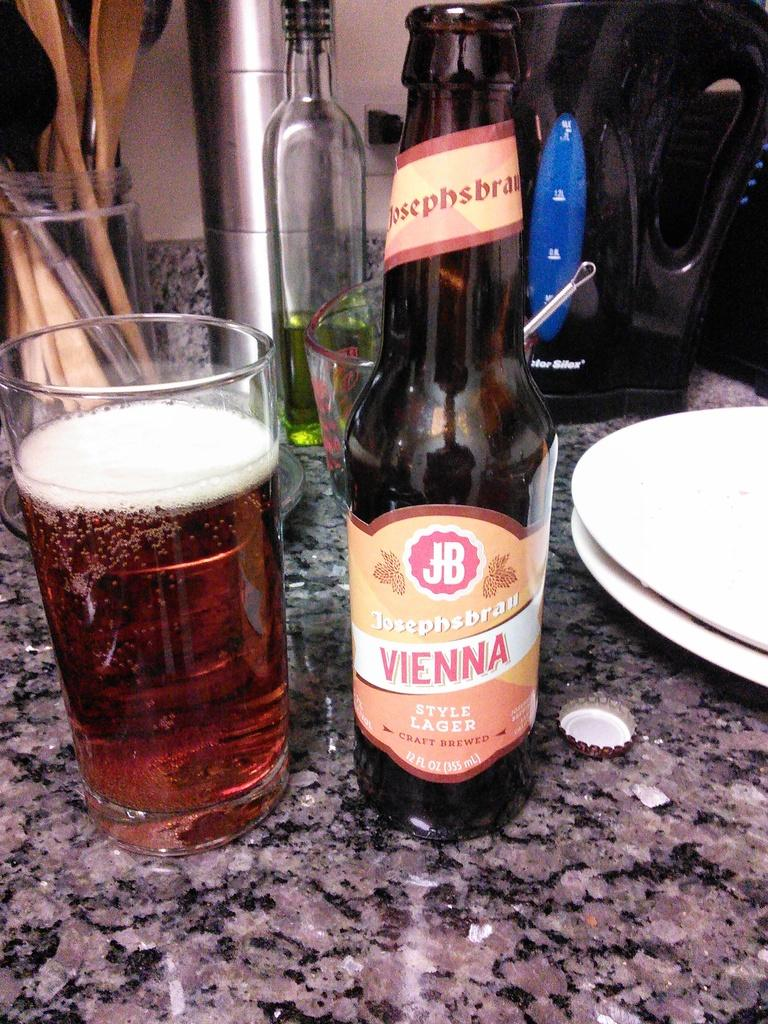<image>
Present a compact description of the photo's key features. A 12 fluid ounce bottle is next to a glass on a counter. 